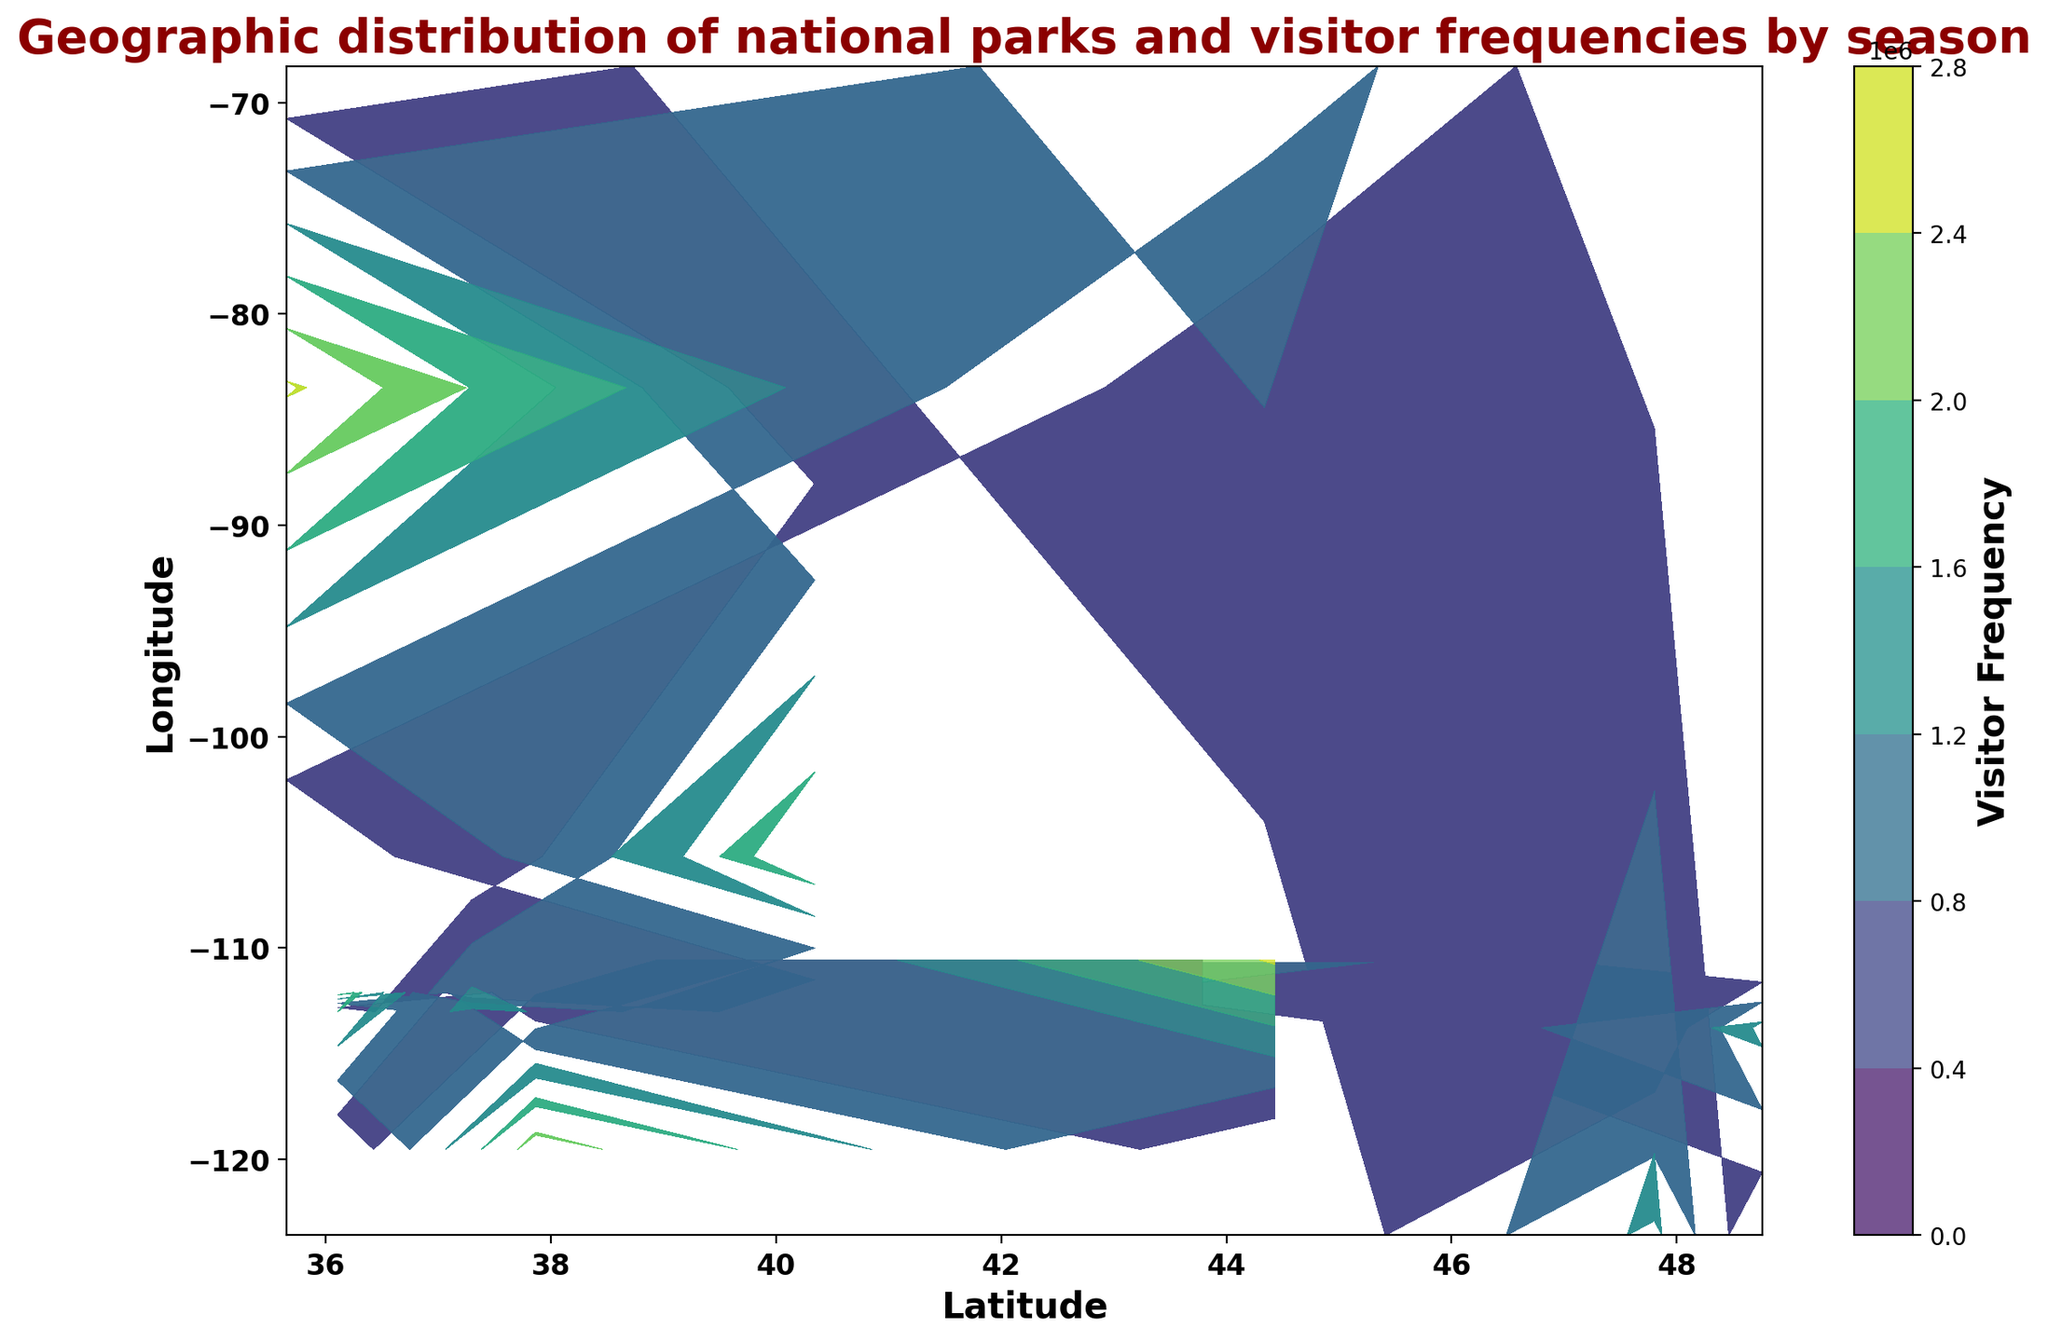What's the latitude range of the national parks with the highest visitor frequency? Identify the color range that indicates the highest visitor frequency (usually the darkest color), then check the latitude values on the x-axis corresponding to these dark colors.
Answer: Around 35 to 48 Which park has the lowest visitor frequency in winter? Find the lowest visitor frequency color in winter and look at the latitude and longitude coordinates. Refer to the plot title or legend if necessary to match the coordinates to a park name.
Answer: Glacier National Park How does the visitor frequency distribution across the seasons affect the overall trends? Sum up the frequencies for each park across seasons by checking the density of contour lines for each park's coordinates, then analyze the variation and peaks in the density distribution.
Answer: Higher in summer, lower in winter Which park has the highest variation in visitor frequency by season? Compare the differences in contour density (visitor frequency) across different seasons for each park, and identify the park with the most significant variation in density between its seasons.
Answer: Yellowstone National Park Is there any correlation between latitude and visitor frequency in summer? Look at the contour colors/levels for summer and observe if there's a trend in color changes along the latitude axis (x-axis). If darker colors shift in a particular direction, there's a correlation.
Answer: No clear correlation Which national park has the highest visitor frequency during the fall? Find the darkest color corresponding to the fall season and look at the latitude and longitude coordinates. Match the coordinates to a park name using the legend or plot title.
Answer: Yellowstone National Park How does the geographic distribution of parks affect visitor frequency? Observe the overall density and clustering of contour lines, which represent visitor frequency, and note how these densities are distributed geographically (latitude and longitude).
Answer: Higher frequency in central/southern locations Which season shows the most significant visitor frequency peak? Look at the various contour colors for each season and identify which season has the most extreme color range (highest density). Check against the highest visitor frequency in the color bar legend.
Answer: Summer How do the visitor frequencies for the national parks in Maine and Washington compare? Compare the contour color densities at the coordinates for Acadia (Maine) and Olympic (Washington) national parks.
Answer: Higher in Washington (Olympic) What color represents 500,000 visitor frequency on the contour plot? Check the color bar legend on the contour plot to identify the specific color representing 500,000 visitors.
Answer: Light green 